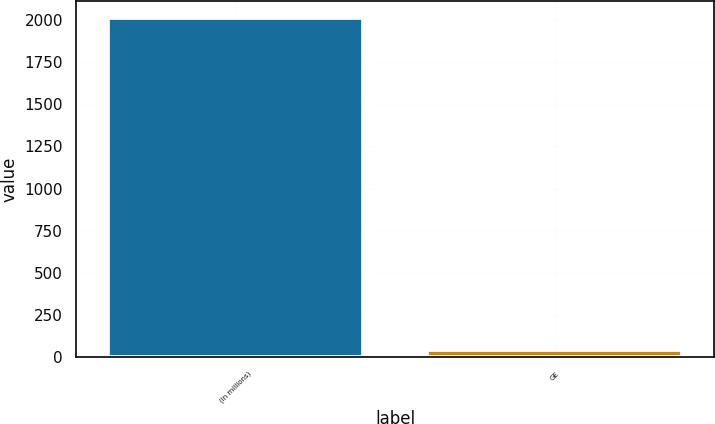Convert chart. <chart><loc_0><loc_0><loc_500><loc_500><bar_chart><fcel>(In millions)<fcel>GE<nl><fcel>2010<fcel>44<nl></chart> 